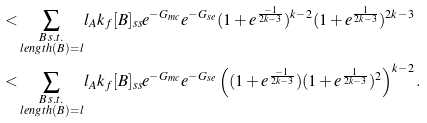Convert formula to latex. <formula><loc_0><loc_0><loc_500><loc_500>< & \sum _ { \substack { B \, s . t . \\ l e n g t h ( B ) = l } } l _ { A } k _ { f } [ B ] _ { s s } e ^ { - G _ { m c } } e ^ { - G _ { s e } } ( 1 + e ^ { \frac { - 1 } { 2 k - 3 } } ) ^ { k - 2 } ( 1 + e ^ { \frac { 1 } { 2 k - 3 } } ) ^ { 2 k - 3 } \\ < & \sum _ { \substack { B \, s . t . \\ l e n g t h ( B ) = l } } l _ { A } k _ { f } [ B ] _ { s s } e ^ { - G _ { m c } } e ^ { - G _ { s e } } \left ( ( 1 + e ^ { \frac { - 1 } { 2 k - 3 } } ) ( 1 + e ^ { \frac { 1 } { 2 k - 3 } } ) ^ { 2 } \right ) ^ { k - 2 } .</formula> 